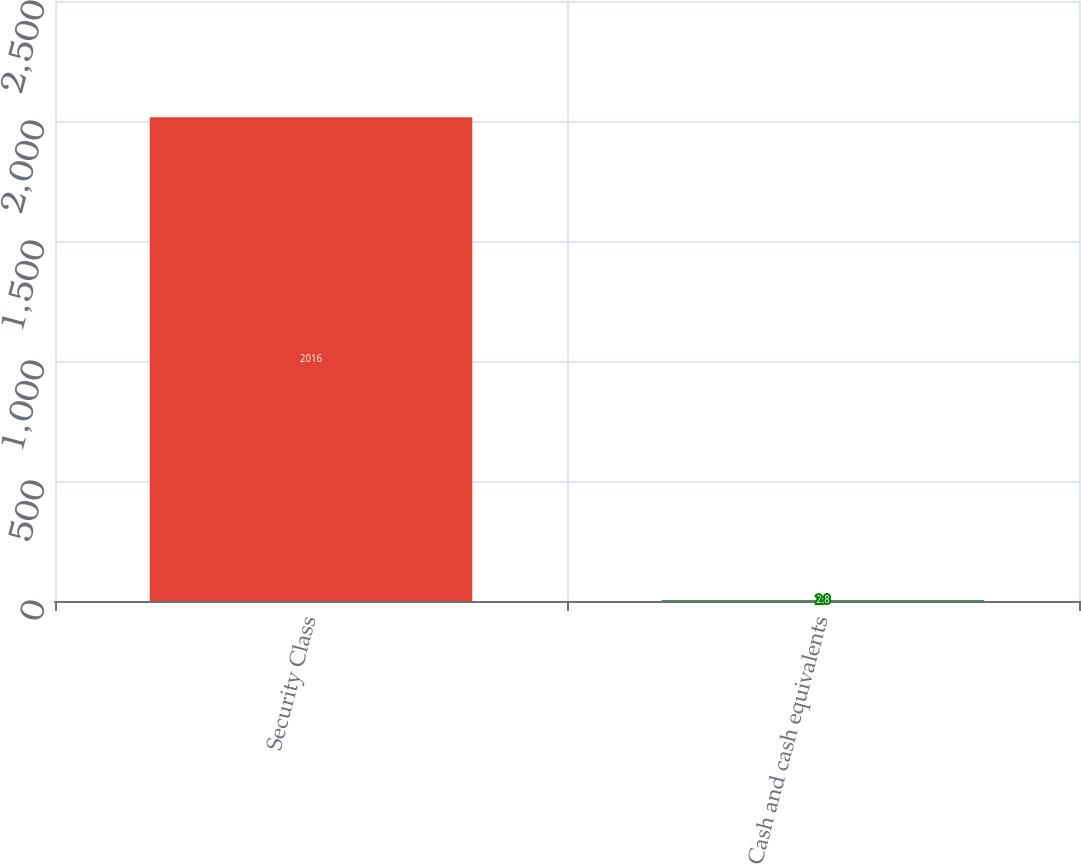Convert chart to OTSL. <chart><loc_0><loc_0><loc_500><loc_500><bar_chart><fcel>Security Class<fcel>Cash and cash equivalents<nl><fcel>2016<fcel>2.8<nl></chart> 